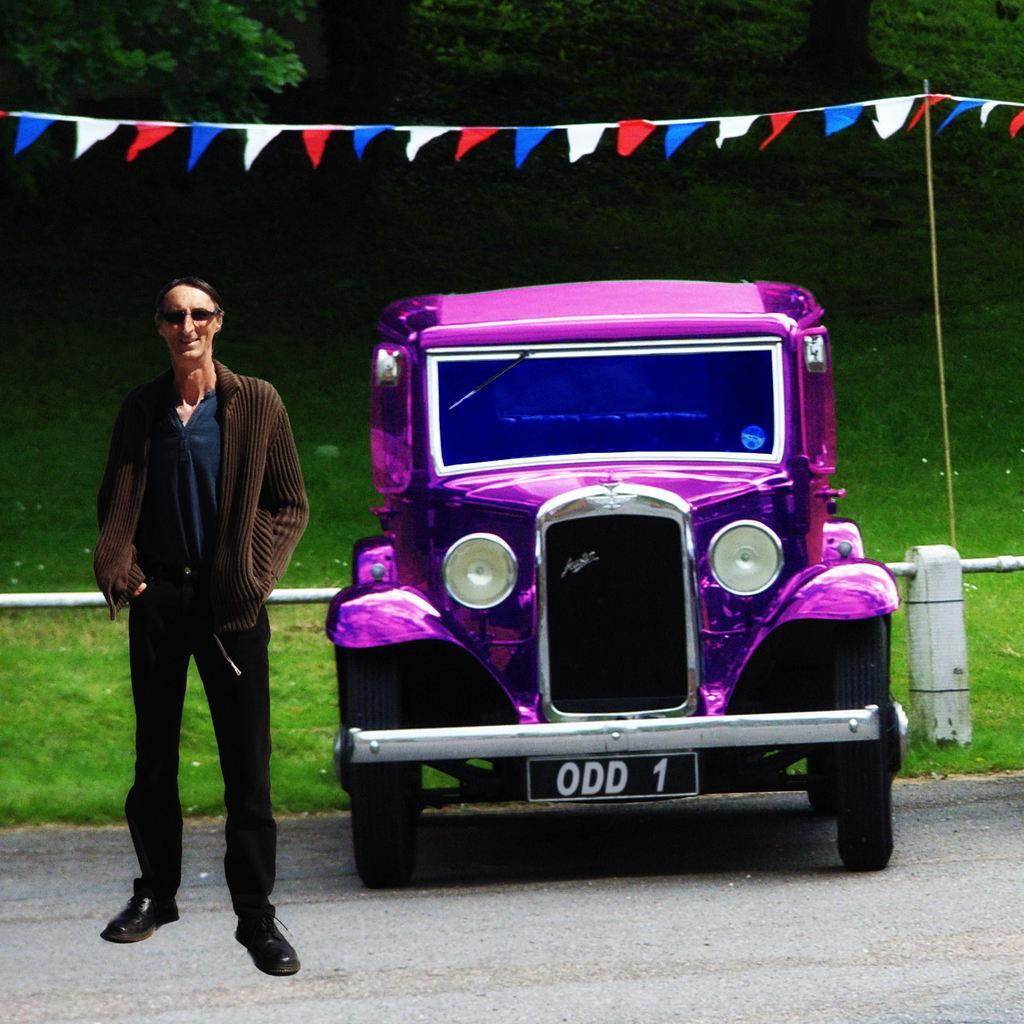In one or two sentences, can you explain what this image depicts? In this image I can see person standing to the side of the vehicle. In the background I can see the fence, grass and the white, red and blue color flags. I can see many trees in the back. 